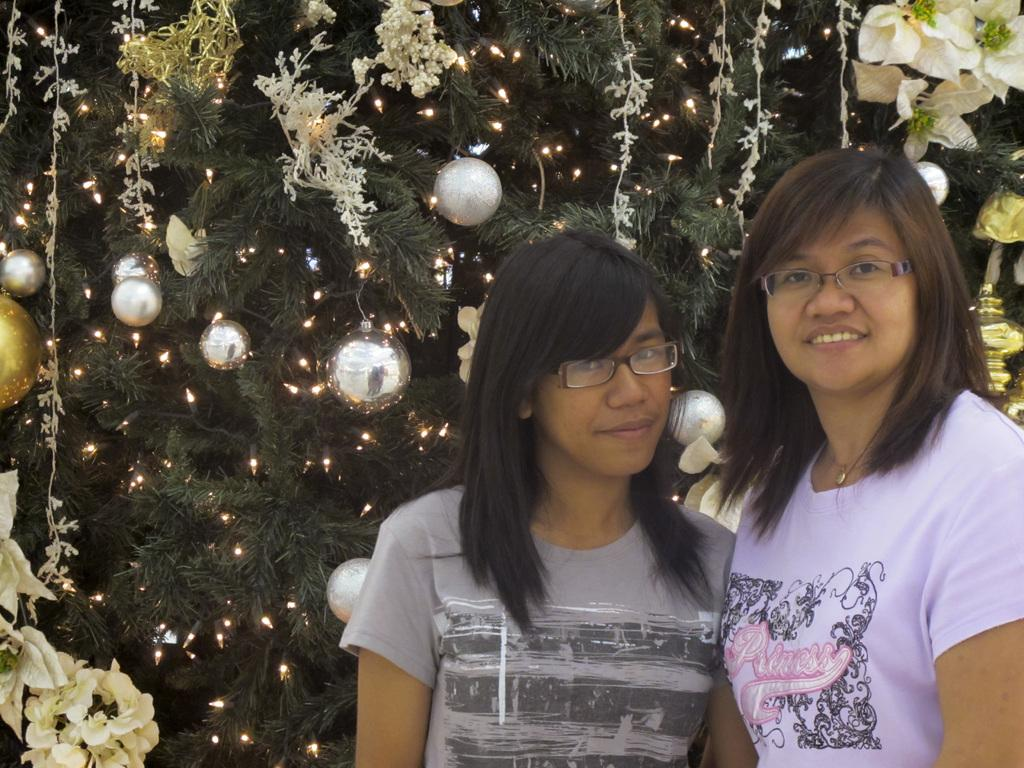How many people are in the image? There are two girls in the image. What is the ethnicity of the girls? The girls are Asian. What is the background of the image? The girls are standing in front of a Christmas tree. What type of gun is the girl holding in the image? There is no gun present in the image; the girls are standing in front of a Christmas tree. 